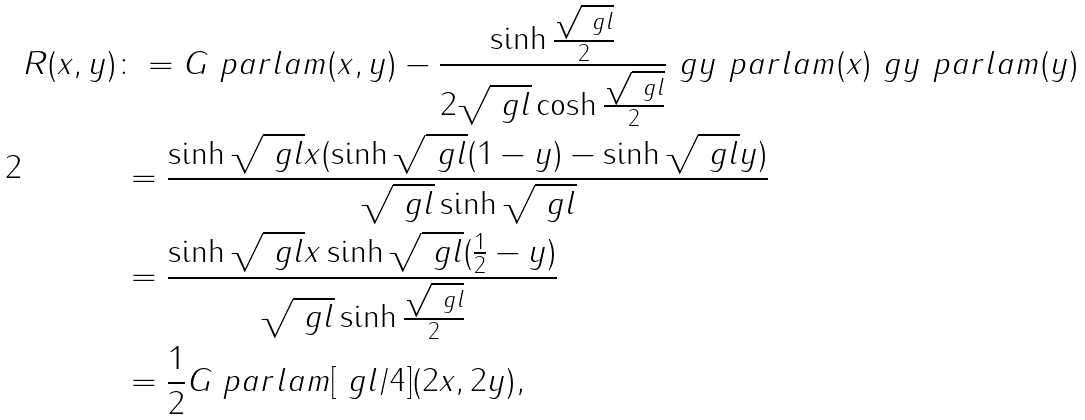Convert formula to latex. <formula><loc_0><loc_0><loc_500><loc_500>R ( x , y ) & \colon = G \ p a r l a m ( x , y ) - \frac { \sinh \frac { \sqrt { \ g l } } { 2 } } { 2 \sqrt { \ g l } \cosh \frac { \sqrt { \ g l } } { 2 } } \ g y \ p a r l a m ( x ) \ g y \ p a r l a m ( y ) \\ & \, = \frac { \sinh \sqrt { \ g l } x ( \sinh \sqrt { \ g l } ( 1 - y ) - \sinh \sqrt { \ g l } y ) } { \sqrt { \ g l } \sinh \sqrt { \ g l } } \\ & \, = \frac { \sinh \sqrt { \ g l } x \sinh { \sqrt { \ g l } ( \frac { 1 } { 2 } - y ) } } { \sqrt { \ g l } \sinh \frac { \sqrt { \ g l } } { 2 } } \\ & \, = \frac { 1 } { 2 } G \ p a r l a m [ \ g l / 4 ] ( 2 x , 2 y ) ,</formula> 